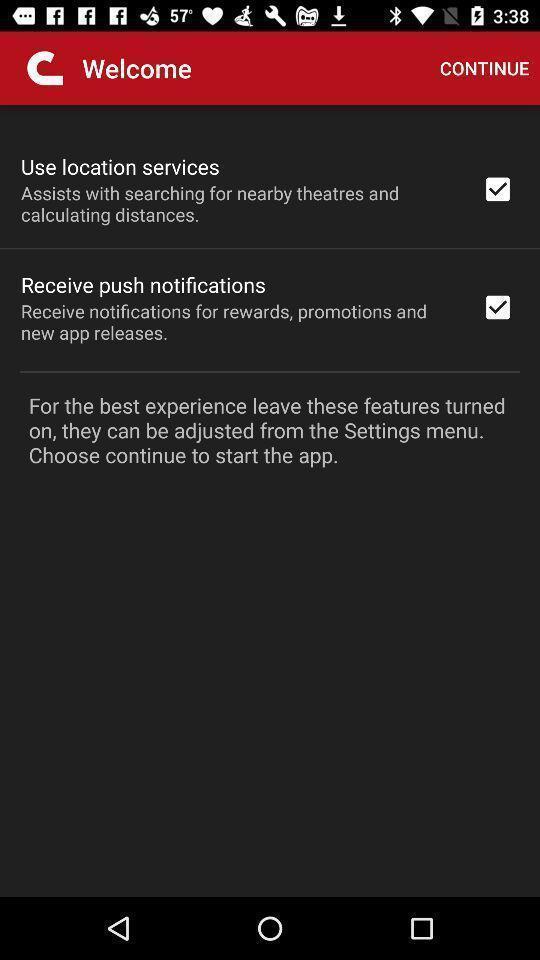What details can you identify in this image? Welcome page with few options in entertainment app. 